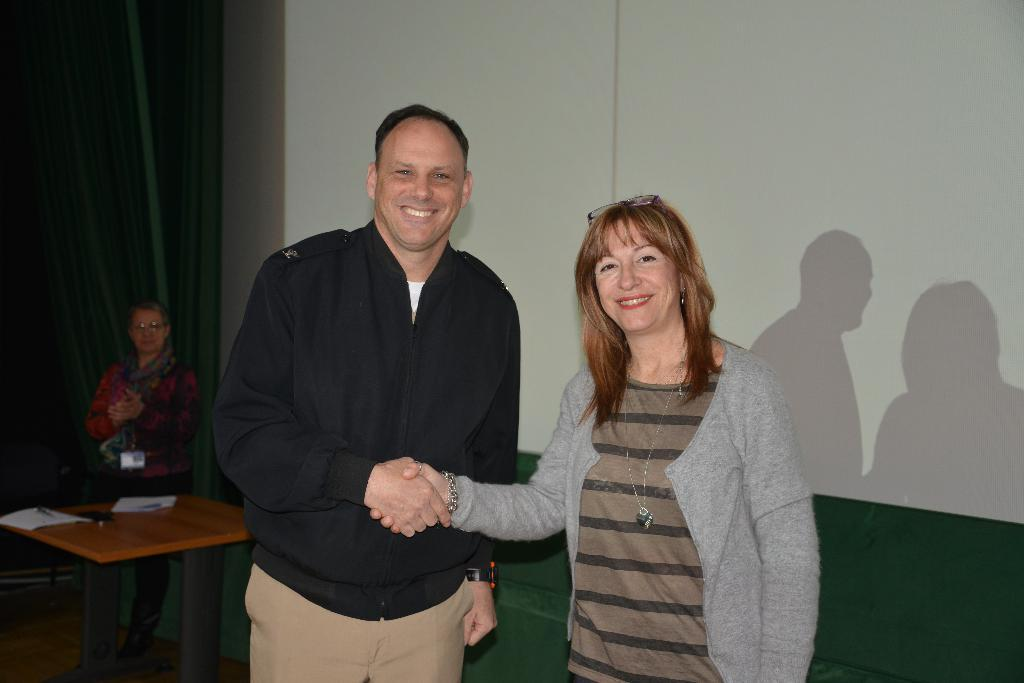Who are the people in the image? There is a man and a woman in the image. What are the man and woman doing in the image? The man and woman are shaking hands in the image. What is the emotional expression of the man and woman in the image? The man and woman are smiling in the image. What time is displayed on the hourglass in the image? There is no hourglass present in the image. Is the queen present in the image? There is no queen present in the image. 